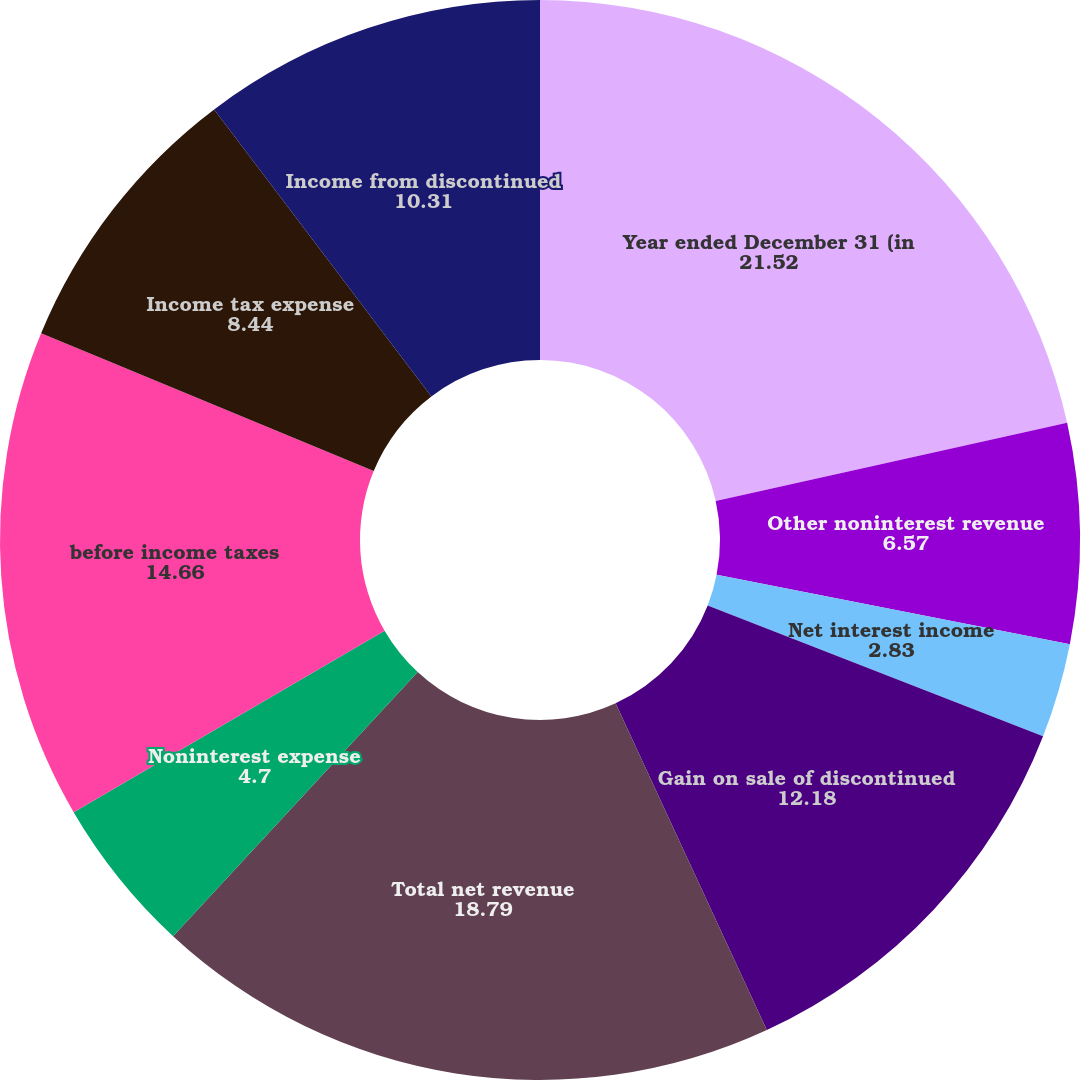Convert chart to OTSL. <chart><loc_0><loc_0><loc_500><loc_500><pie_chart><fcel>Year ended December 31 (in<fcel>Other noninterest revenue<fcel>Net interest income<fcel>Gain on sale of discontinued<fcel>Total net revenue<fcel>Noninterest expense<fcel>before income taxes<fcel>Income tax expense<fcel>Income from discontinued<nl><fcel>21.52%<fcel>6.57%<fcel>2.83%<fcel>12.18%<fcel>18.79%<fcel>4.7%<fcel>14.66%<fcel>8.44%<fcel>10.31%<nl></chart> 